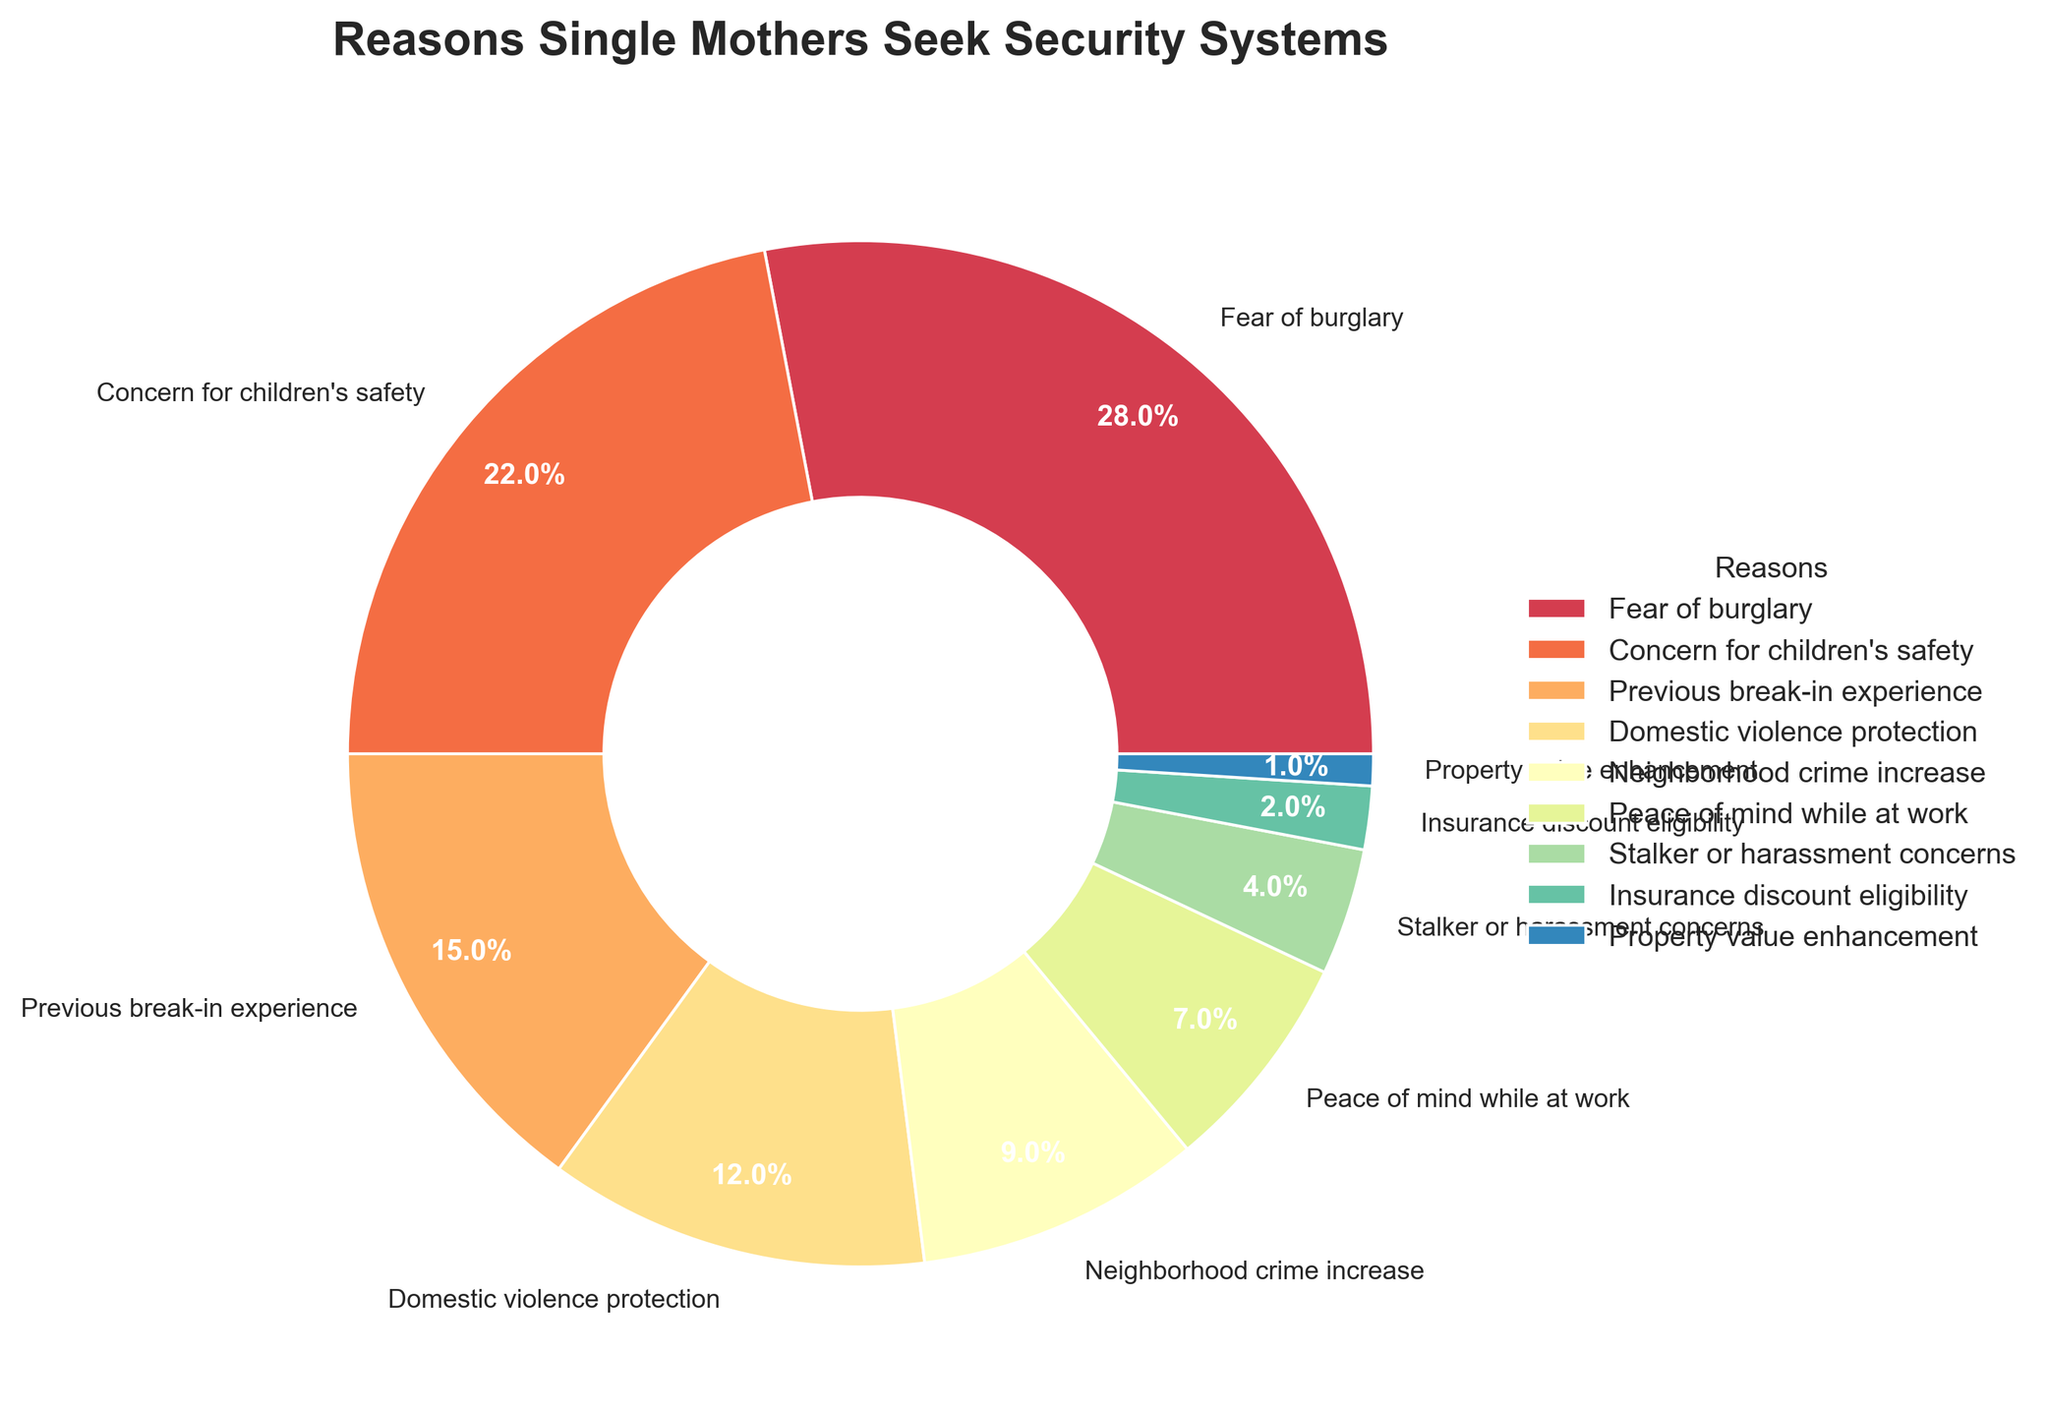Which reason is cited most frequently by single mothers for seeking security systems? The figure shows the largest segment in the pie chart is labeled "Fear of burglary" with a percentage of 28%. Therefore, "Fear of burglary" is the most frequently cited reason.
Answer: Fear of burglary How much more frequently is "Fear of burglary" cited compared to "Property value enhancement"? "Fear of burglary" is cited by 28% of the respondents, while "Property value enhancement" is cited by 1%. The difference is 28% - 1% = 27%. So, "Fear of burglary" is cited 27% more frequently.
Answer: 27% What are the three least common reasons for seeking security systems according to the chart? The three smallest segments in the pie chart are labeled "Property value enhancement" with 1%, "Insurance discount eligibility" with 2%, and "Stalker or harassment concerns" with 4%.
Answer: Property value enhancement, Insurance discount eligibility, Stalker or harassment concerns Which reason is more common: "Concern for children's safety" or "Previous break-in experience"? By comparing the pie chart segments, "Concern for children's safety" is 22% whereas "Previous break-in experience" is 15%. Therefore, "Concern for children's safety" is more common.
Answer: Concern for children's safety What is the combined percentage of respondents who cited "Domestic violence protection" and "Neighborhood crime increase"? According to the pie chart, "Domestic violence protection" is cited by 12% of respondents and "Neighborhood crime increase" by 9%. The combined percentage is 12% + 9% = 21%.
Answer: 21% How many percentage points higher is "Domestic violence protection" compared to "Peace of mind while at work"? The percentage for "Domestic violence protection" is 12%, and for "Peace of mind while at work" it is 7%. The difference is 12% - 7% = 5%.
Answer: 5% Which reasons account for more than 20% of the responses each? The pie chart shows that only "Fear of burglary" (28%) and "Concern for children's safety" (22%) account for more than 20% of the responses each.
Answer: Fear of burglary, Concern for children's safety Which reason takes up nearly a quarter of the pie chart? The segment labeled "Fear of burglary" takes up 28% of the pie chart, which is close to a quarter.
Answer: Fear of burglary What is the total percentage of respondents who cited insurance discount eligibility or property value enhancement as their reason? According to the pie chart, "Insurance discount eligibility" is 2% and "Property value enhancement" is 1%. The total percentage is 2% + 1% = 3%.
Answer: 3% What percentage do respondents who cited "Stalker or harassment concerns" and "Neighborhood crime increase" together represent? "Stalker or harassment concerns" represent 4% of respondents and "Neighborhood crime increase" represent 9%. Together, they represent 4% + 9% = 13%.
Answer: 13% 